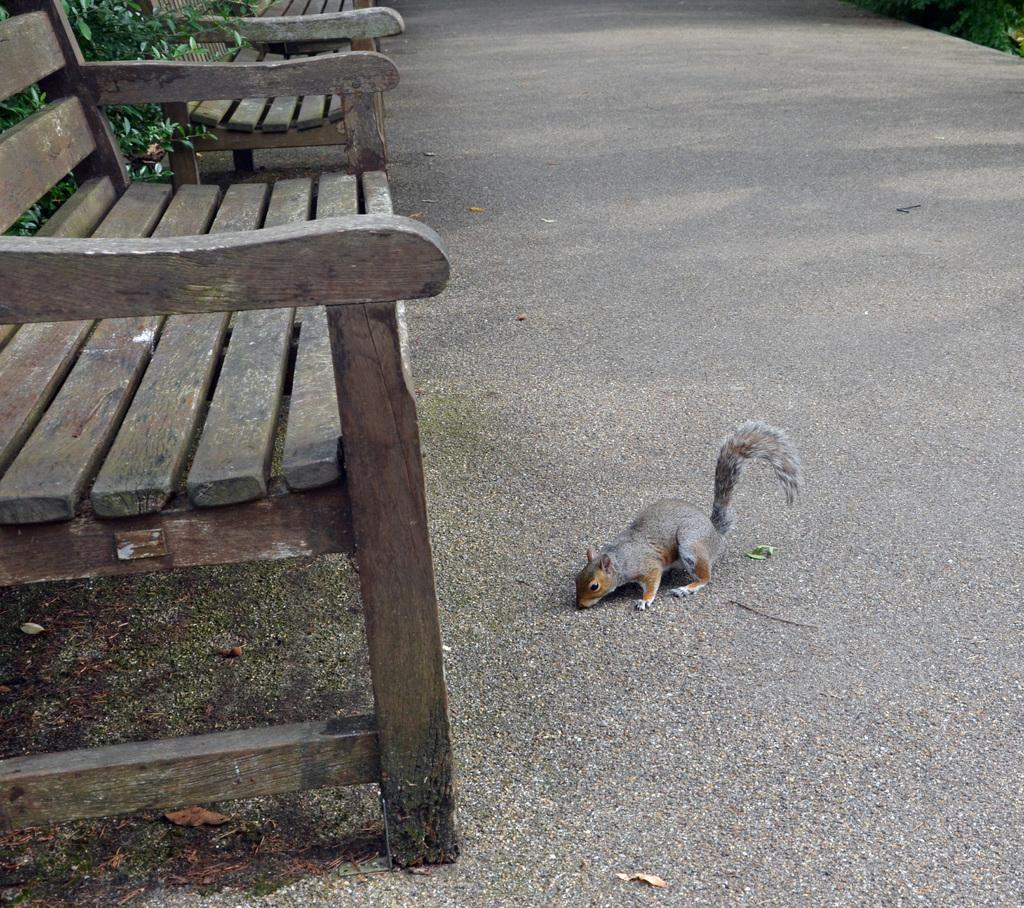What type of seating is visible in the image? There is a bench in the image. What animal can be seen near the bench? There is a squirrel in front of the bench. What items are on the list that the squirrel is holding in the image? There is no list present in the image, and the squirrel is not holding any items. 